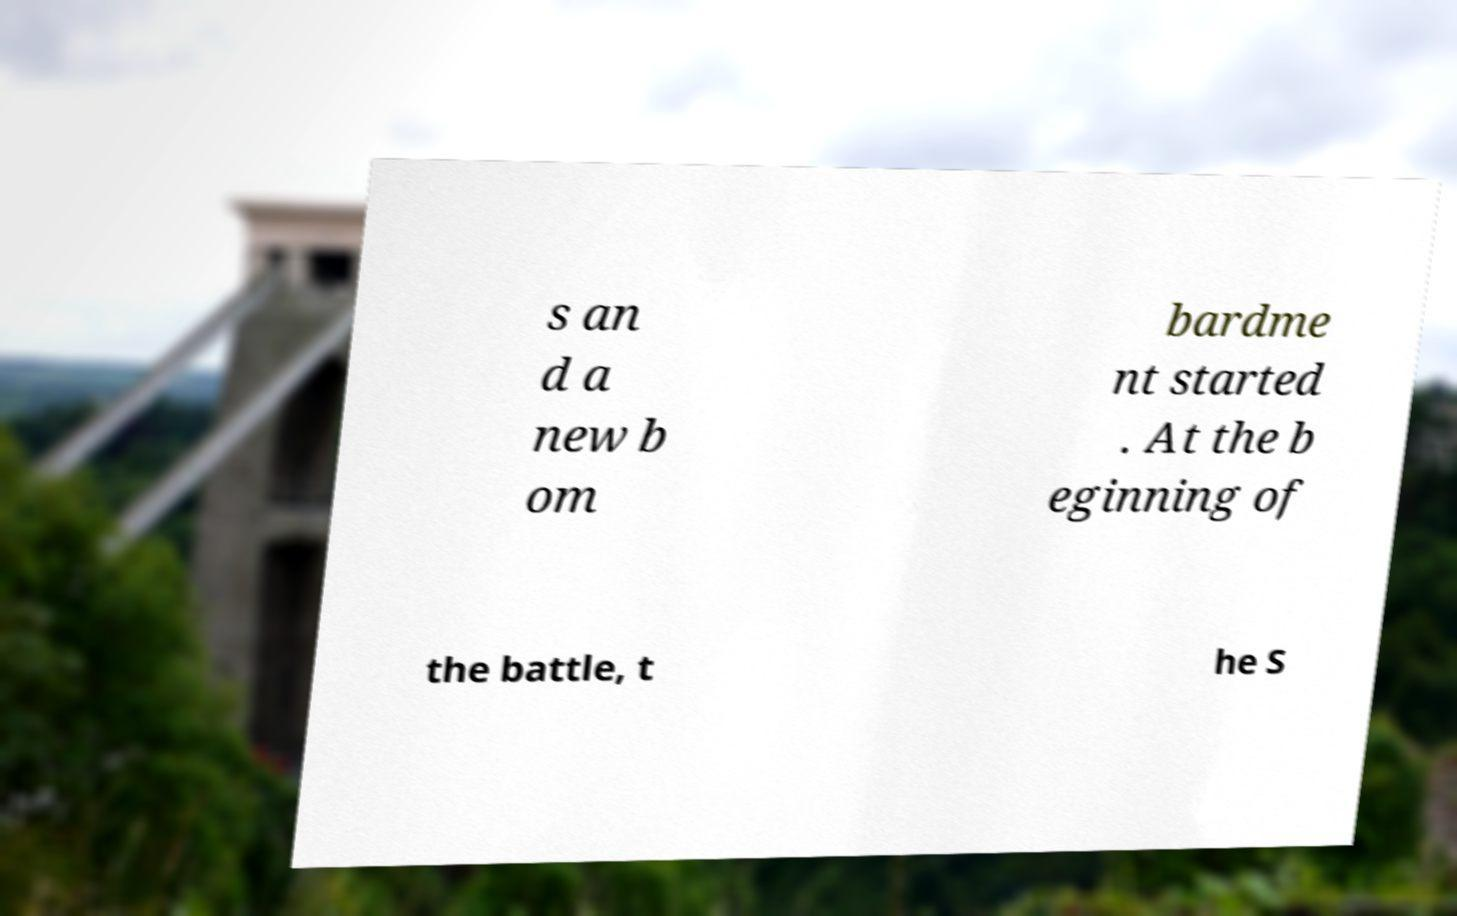For documentation purposes, I need the text within this image transcribed. Could you provide that? s an d a new b om bardme nt started . At the b eginning of the battle, t he S 